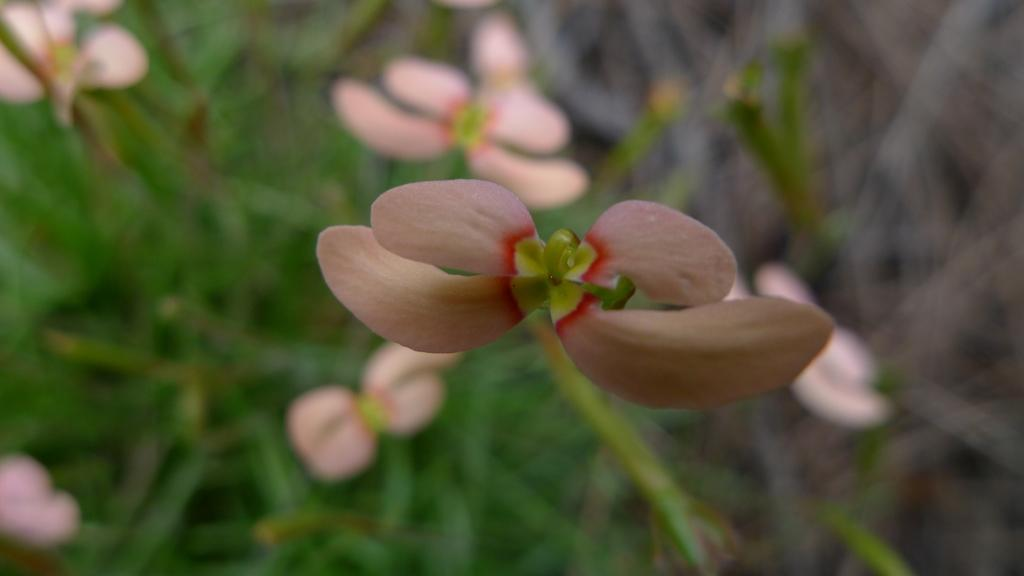What is the main subject of the image? There is a flower in the image. How would you describe the background of the image? The background appears blurry. What else can be seen in the background besides the blurry effect? There are flowers and leaves in the background. What is the purpose of the spy in the image? There is no spy present in the image; it features a flower and a blurry background with flowers and leaves. 